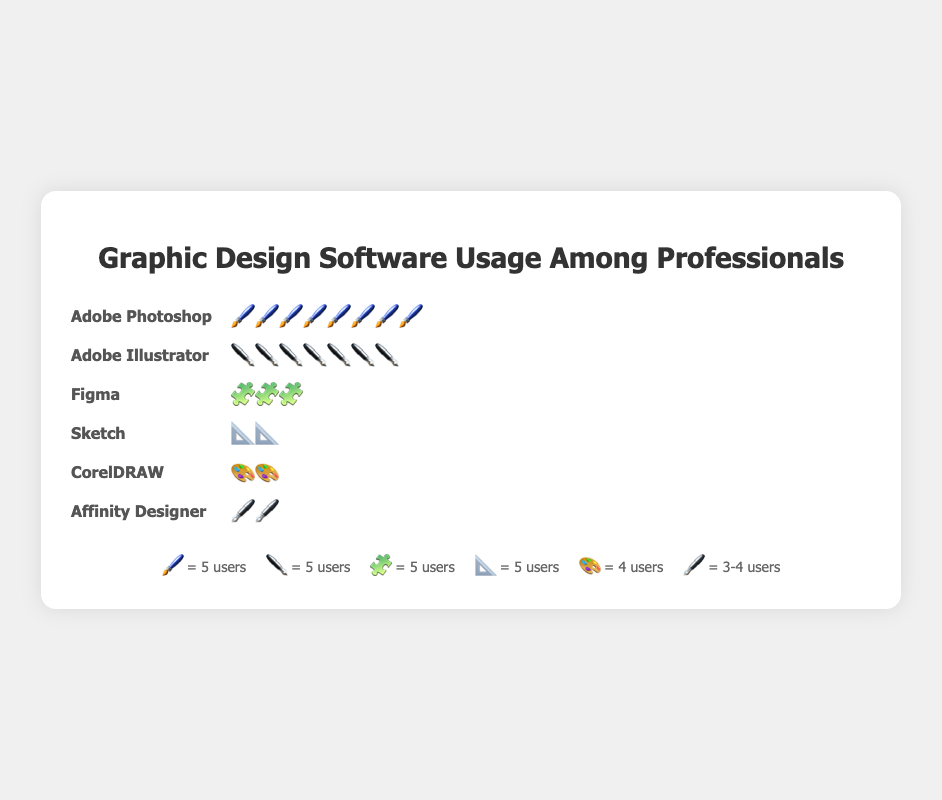Which software has the highest usage among professionals? The software with the highest usage is the one with the most icons in the plot. Adobe Photoshop has the most icons (eight) representing it.
Answer: Adobe Photoshop How many users does Adobe Illustrator have? Each icon represents 5 users, and Adobe Illustrator has seven icons, so 7 * 5 = 35 users.
Answer: 35 users Compare the number of users of Adobe Photoshop and Figma. Adobe Photoshop has eight icons, representing 40 users (8 * 5) and Figma has three icons, representing 15 users (3 * 5). So, Adobe Photoshop has more users than Figma.
Answer: Adobe Photoshop has more users Which software has fewer users, Sketch or Affinity Designer? Sketch has two icons, each representing 5 users, so it has 10 users (2 * 5). Affinity Designer has two icons, each representing 3-4 users, so it has 7 users. Therefore, Affinity Designer has fewer users.
Answer: Affinity Designer How many total users are represented in the plot? Sum the users from each software: Adobe Photoshop (40), Adobe Illustrator (35), Figma (15), Sketch (10), CorelDRAW (8), and Affinity Designer (7). Total = 40 + 35 + 15 + 10 + 8 + 7 = 115.
Answer: 115 users What is the difference in the number of users between Adobe Illustrator and CorelDRAW? Adobe Illustrator has seven icons representing 35 users (7 * 5), and CorelDRAW has two icons representing 8 users. Difference = 35 - 8 = 27.
Answer: 27 users What percentage of the total users use Figma? Total users = 115. Figma users = 15. Percentage = (15 / 115) * 100 ≈ 13.04%.
Answer: 13.04% Which software has the second-highest usage? Based on the number of icons, Adobe Illustrator has the second-highest usage with 35 users.
Answer: Adobe Illustrator 